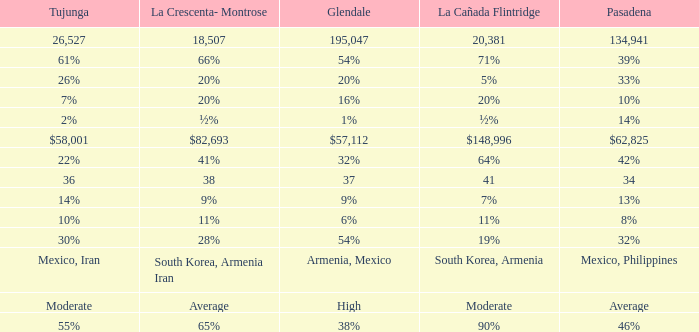What is the figure for Pasadena when Tujunga is 36? 34.0. 